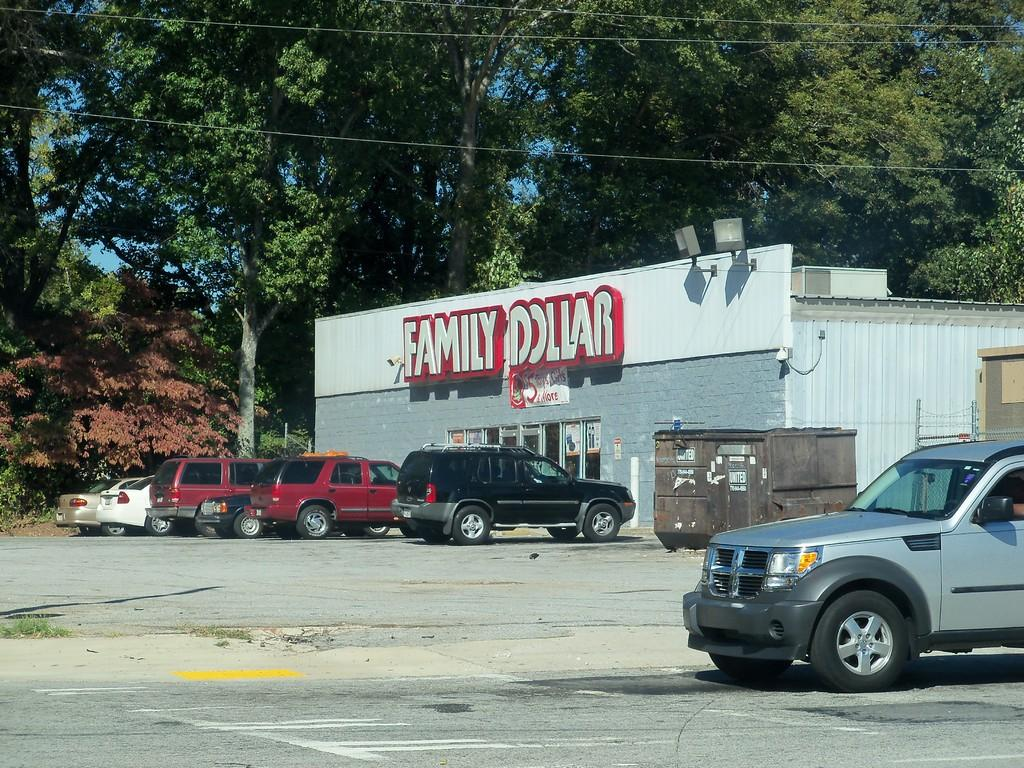What can be seen in the middle of the image? There are cars parked in the parking lot in the middle of the image. What is located in front of the cars? There is a building in front of the cars. What type of natural elements can be seen in the background of the image? There are trees visible in the background of the image. Can you see a goose flying with its wing in the image? There is no goose or wing present in the image. What type of connection can be seen between the cars and the building in the image? There is no visible connection between the cars and the building in the image; they are simply located in proximity to each other. 